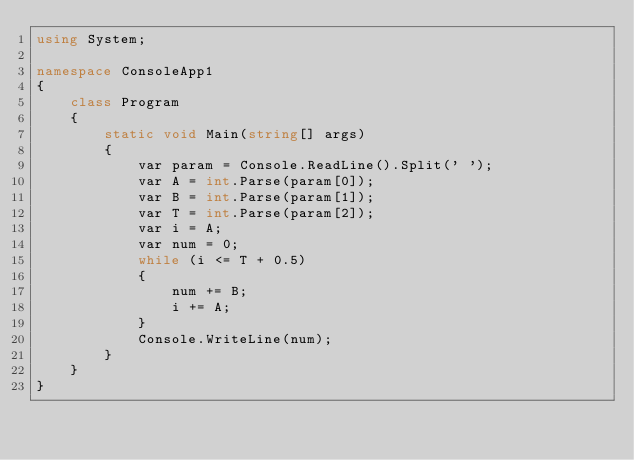Convert code to text. <code><loc_0><loc_0><loc_500><loc_500><_C#_>using System;

namespace ConsoleApp1
{
    class Program
    {
        static void Main(string[] args)
        {
            var param = Console.ReadLine().Split(' ');
            var A = int.Parse(param[0]);
            var B = int.Parse(param[1]);
            var T = int.Parse(param[2]);
            var i = A;
            var num = 0;
            while (i <= T + 0.5)
            {
                num += B; 
                i += A;
            }
            Console.WriteLine(num);
        }
    }
}
</code> 